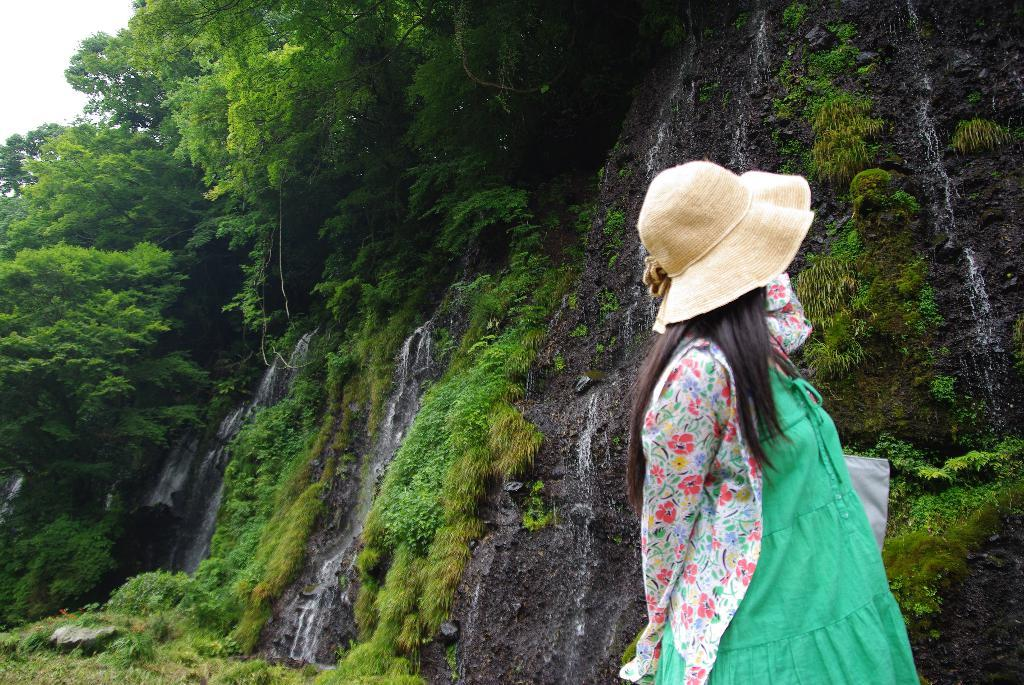What is the main subject of the image? The main subject of the image is a woman. What is the woman wearing on her head? The woman is wearing a hat. What can be seen in the background of the image? There are trees in the background of the image. Is there any snow visible in the image? There is no snow present in the image. Can you see a goose in the image? There is no goose present in the image. Is there a circle drawn on the woman's hat? There is no circle drawn on the woman's hat in the image. 